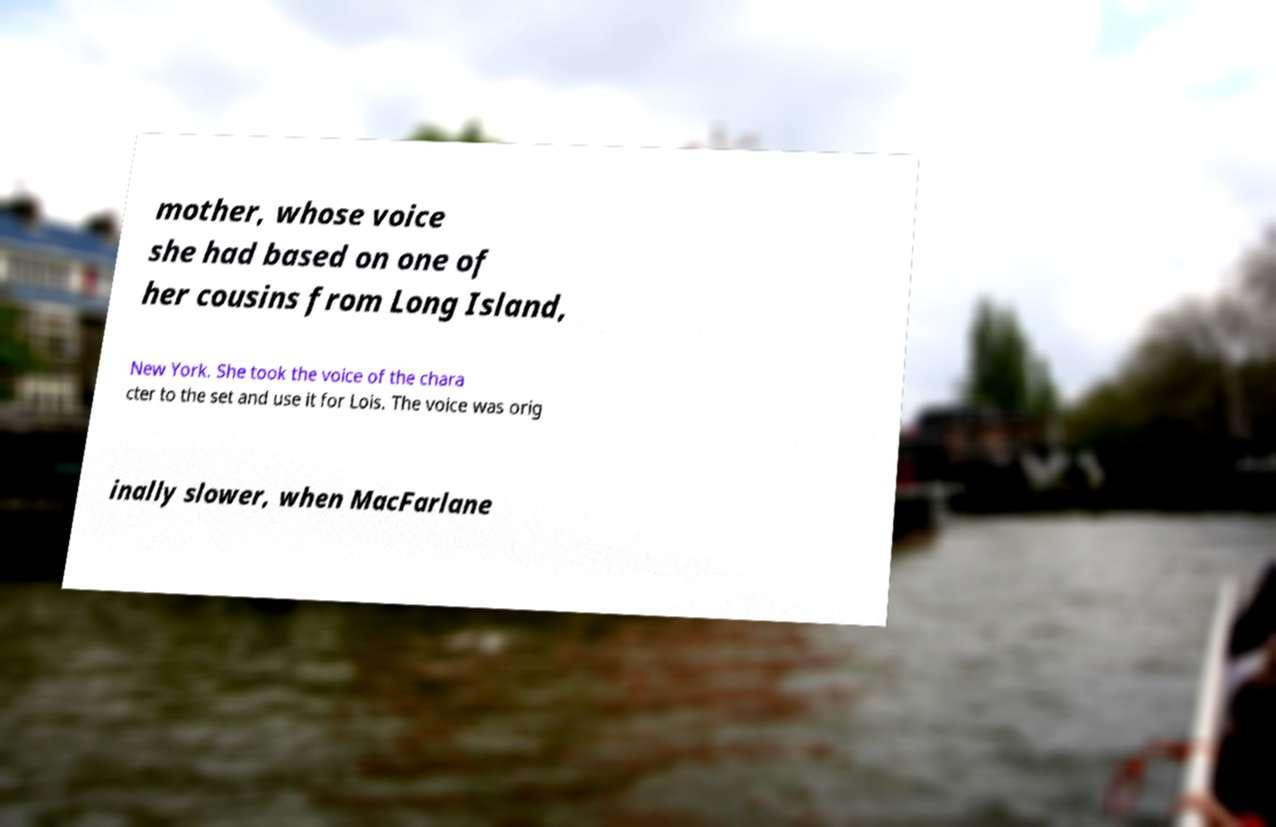Please read and relay the text visible in this image. What does it say? mother, whose voice she had based on one of her cousins from Long Island, New York. She took the voice of the chara cter to the set and use it for Lois. The voice was orig inally slower, when MacFarlane 